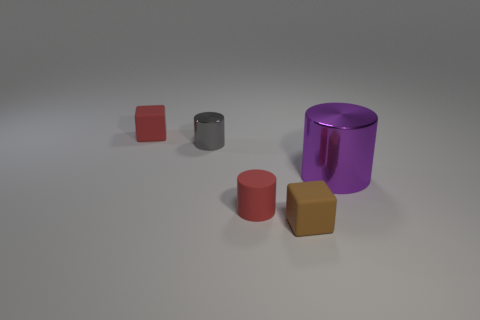Subtract all large purple cylinders. How many cylinders are left? 2 Add 1 matte cylinders. How many objects exist? 6 Subtract 2 cylinders. How many cylinders are left? 1 Subtract all blue blocks. How many cyan cylinders are left? 0 Subtract all matte cylinders. Subtract all tiny red things. How many objects are left? 2 Add 4 small red matte objects. How many small red matte objects are left? 6 Add 1 large shiny things. How many large shiny things exist? 2 Subtract all gray cylinders. How many cylinders are left? 2 Subtract 0 gray balls. How many objects are left? 5 Subtract all cylinders. How many objects are left? 2 